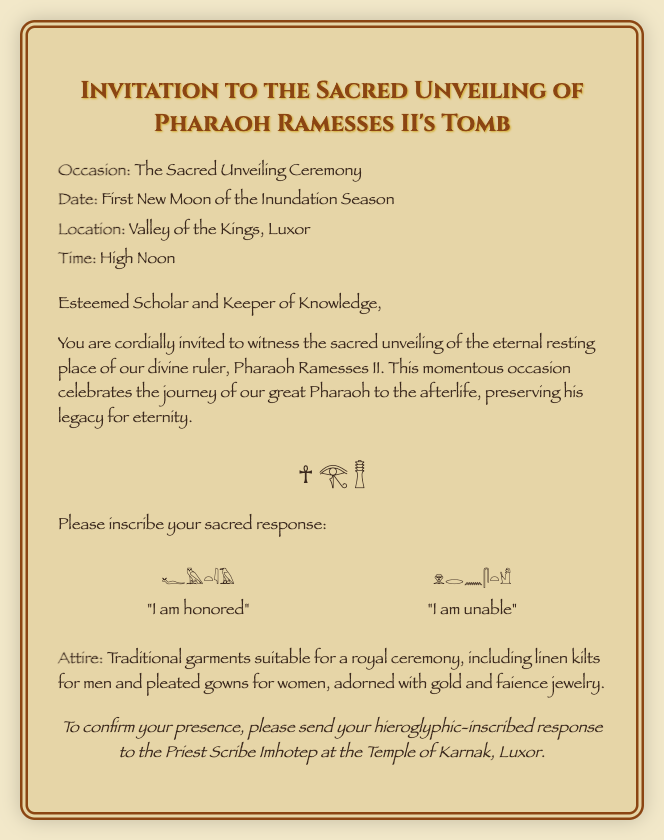What is the occasion? The occasion is clearly stated in the document as "The Sacred Unveiling Ceremony."
Answer: The Sacred Unveiling Ceremony What is the date of the event? The date of the event is specified as "First New Moon of the Inundation Season."
Answer: First New Moon of the Inundation Season Where is the ceremony taking place? The location of the ceremony is mentioned as "Valley of the Kings, Luxor."
Answer: Valley of the Kings, Luxor What time is the ceremony scheduled for? The document indicates that the ceremony will take place at "High Noon."
Answer: High Noon What is the response for attending? The document provides the hieroglyphic response for attending, which is "𓆑𓅓𓏏𓇋𓄿."
Answer: 𓆑𓅓𓏏𓇋𓄿 What is the response for inability to attend? The document provides the hieroglyphic response for declining, which is "𓁷𓂋𓈖𓋴𓏏𓀹."
Answer: 𓁷𓂋𓈖𓋴𓏏𓀹 What attire is suggested for the ceremony? The document specifies the attire as "Traditional garments suitable for a royal ceremony."
Answer: Traditional garments suitable for a royal ceremony Who should responses be sent to? The document states that responses should be sent to "the Priest Scribe Imhotep."
Answer: the Priest Scribe Imhotep 